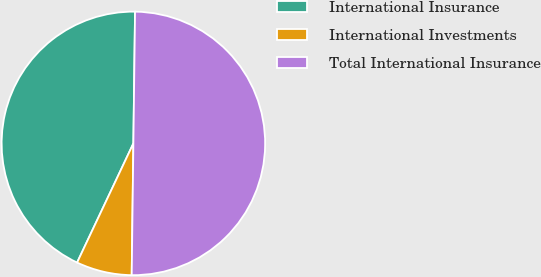<chart> <loc_0><loc_0><loc_500><loc_500><pie_chart><fcel>International Insurance<fcel>International Investments<fcel>Total International Insurance<nl><fcel>43.18%<fcel>6.82%<fcel>50.0%<nl></chart> 